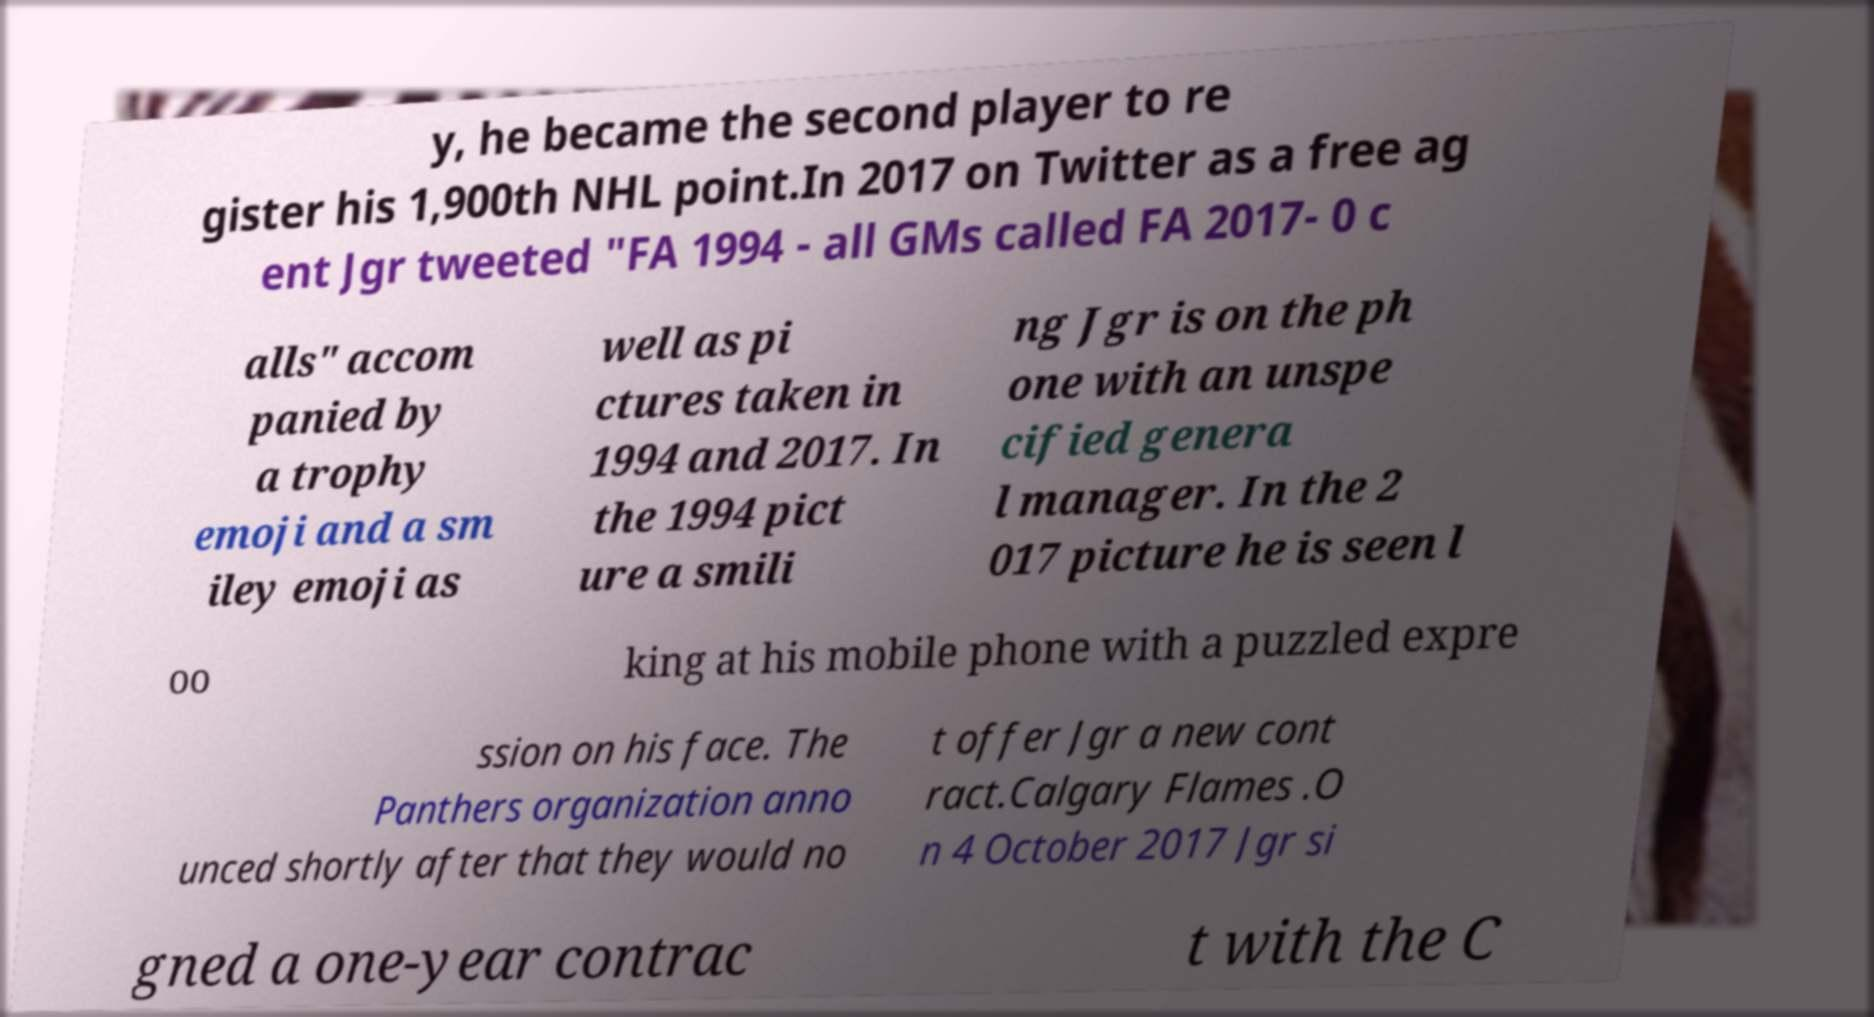I need the written content from this picture converted into text. Can you do that? y, he became the second player to re gister his 1,900th NHL point.In 2017 on Twitter as a free ag ent Jgr tweeted "FA 1994 - all GMs called FA 2017- 0 c alls" accom panied by a trophy emoji and a sm iley emoji as well as pi ctures taken in 1994 and 2017. In the 1994 pict ure a smili ng Jgr is on the ph one with an unspe cified genera l manager. In the 2 017 picture he is seen l oo king at his mobile phone with a puzzled expre ssion on his face. The Panthers organization anno unced shortly after that they would no t offer Jgr a new cont ract.Calgary Flames .O n 4 October 2017 Jgr si gned a one-year contrac t with the C 